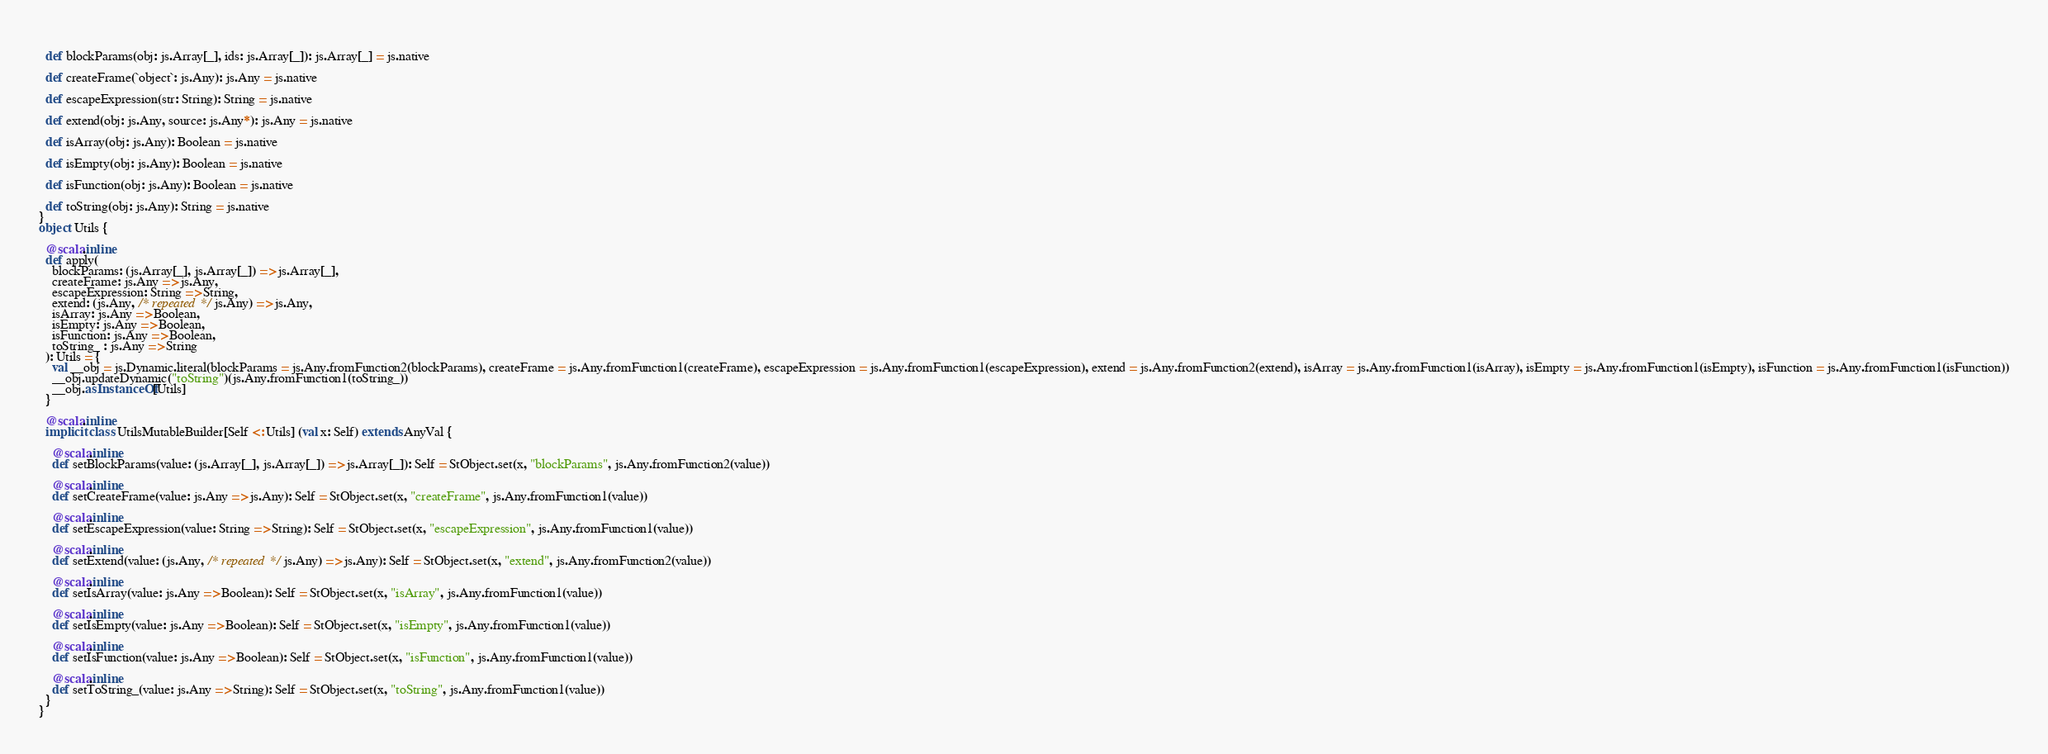Convert code to text. <code><loc_0><loc_0><loc_500><loc_500><_Scala_>  
  def blockParams(obj: js.Array[_], ids: js.Array[_]): js.Array[_] = js.native
  
  def createFrame(`object`: js.Any): js.Any = js.native
  
  def escapeExpression(str: String): String = js.native
  
  def extend(obj: js.Any, source: js.Any*): js.Any = js.native
  
  def isArray(obj: js.Any): Boolean = js.native
  
  def isEmpty(obj: js.Any): Boolean = js.native
  
  def isFunction(obj: js.Any): Boolean = js.native
  
  def toString(obj: js.Any): String = js.native
}
object Utils {
  
  @scala.inline
  def apply(
    blockParams: (js.Array[_], js.Array[_]) => js.Array[_],
    createFrame: js.Any => js.Any,
    escapeExpression: String => String,
    extend: (js.Any, /* repeated */ js.Any) => js.Any,
    isArray: js.Any => Boolean,
    isEmpty: js.Any => Boolean,
    isFunction: js.Any => Boolean,
    toString_ : js.Any => String
  ): Utils = {
    val __obj = js.Dynamic.literal(blockParams = js.Any.fromFunction2(blockParams), createFrame = js.Any.fromFunction1(createFrame), escapeExpression = js.Any.fromFunction1(escapeExpression), extend = js.Any.fromFunction2(extend), isArray = js.Any.fromFunction1(isArray), isEmpty = js.Any.fromFunction1(isEmpty), isFunction = js.Any.fromFunction1(isFunction))
    __obj.updateDynamic("toString")(js.Any.fromFunction1(toString_))
    __obj.asInstanceOf[Utils]
  }
  
  @scala.inline
  implicit class UtilsMutableBuilder[Self <: Utils] (val x: Self) extends AnyVal {
    
    @scala.inline
    def setBlockParams(value: (js.Array[_], js.Array[_]) => js.Array[_]): Self = StObject.set(x, "blockParams", js.Any.fromFunction2(value))
    
    @scala.inline
    def setCreateFrame(value: js.Any => js.Any): Self = StObject.set(x, "createFrame", js.Any.fromFunction1(value))
    
    @scala.inline
    def setEscapeExpression(value: String => String): Self = StObject.set(x, "escapeExpression", js.Any.fromFunction1(value))
    
    @scala.inline
    def setExtend(value: (js.Any, /* repeated */ js.Any) => js.Any): Self = StObject.set(x, "extend", js.Any.fromFunction2(value))
    
    @scala.inline
    def setIsArray(value: js.Any => Boolean): Self = StObject.set(x, "isArray", js.Any.fromFunction1(value))
    
    @scala.inline
    def setIsEmpty(value: js.Any => Boolean): Self = StObject.set(x, "isEmpty", js.Any.fromFunction1(value))
    
    @scala.inline
    def setIsFunction(value: js.Any => Boolean): Self = StObject.set(x, "isFunction", js.Any.fromFunction1(value))
    
    @scala.inline
    def setToString_(value: js.Any => String): Self = StObject.set(x, "toString", js.Any.fromFunction1(value))
  }
}
</code> 